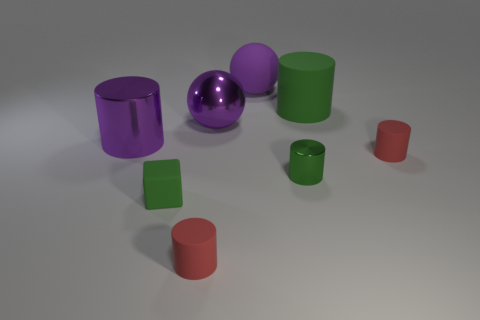Subtract all red cylinders. How many cylinders are left? 3 Subtract all green metallic cylinders. How many cylinders are left? 4 Add 1 big metallic cylinders. How many objects exist? 9 Subtract all blue cylinders. Subtract all cyan balls. How many cylinders are left? 5 Subtract all red cubes. How many purple cylinders are left? 1 Subtract all big purple metal objects. Subtract all big rubber objects. How many objects are left? 4 Add 6 large cylinders. How many large cylinders are left? 8 Add 7 red objects. How many red objects exist? 9 Subtract 0 green spheres. How many objects are left? 8 Subtract all cylinders. How many objects are left? 3 